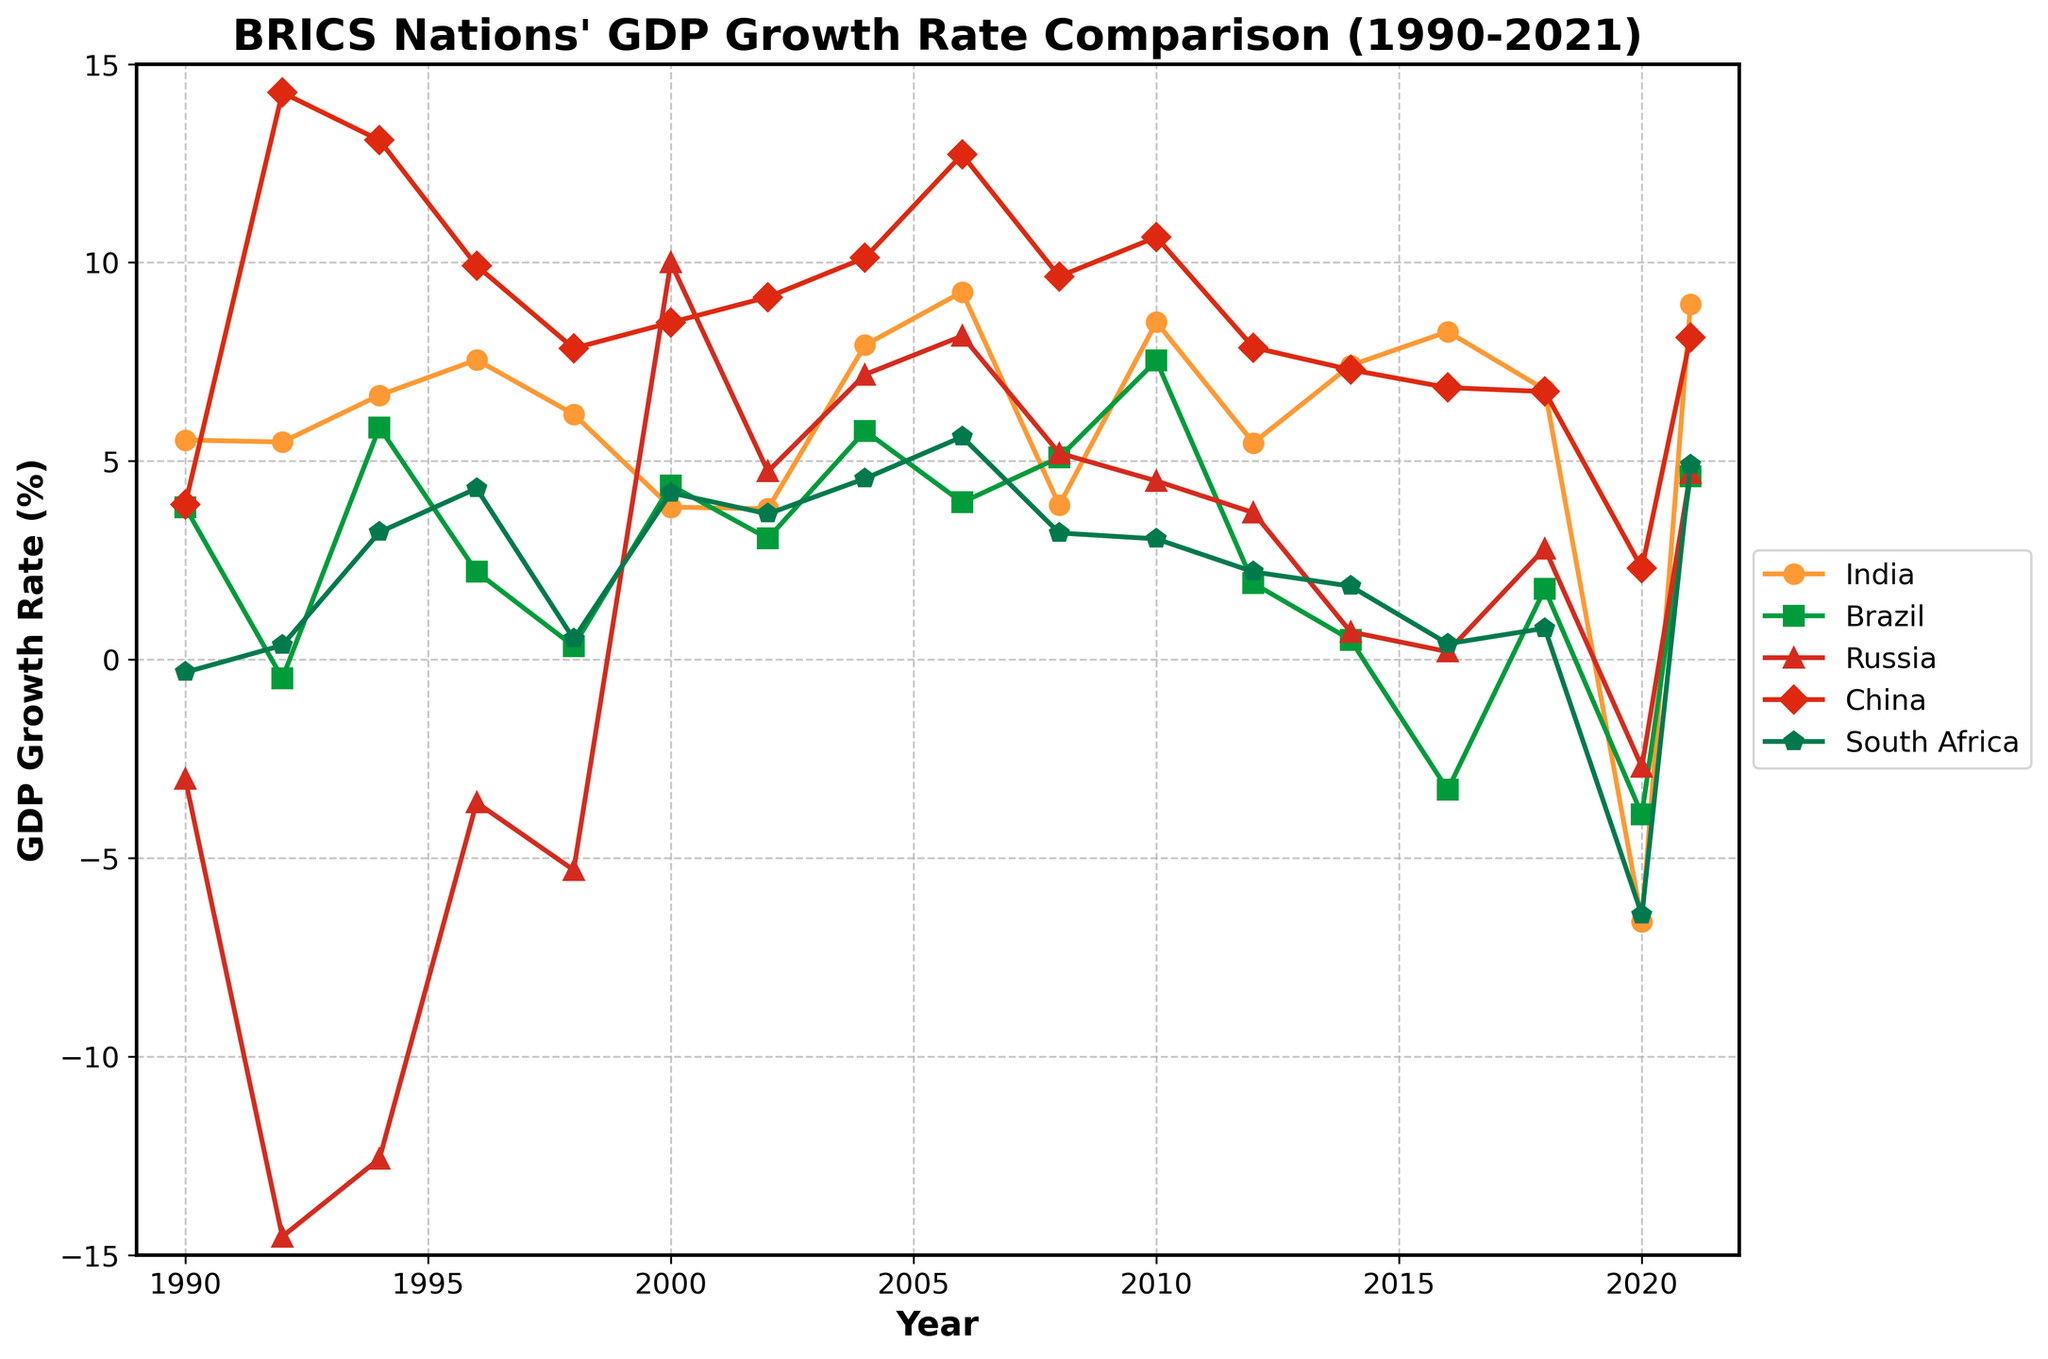What year did India experience its highest GDP growth rate, and what was the rate? To determine the highest GDP growth rate for India, find the peak point on India’s line in the plot. The peak point is at 2021, where India's GDP growth rate is 8.95%.
Answer: 2021, 8.95% Compare the GDP growth rates of India and Brazil in 2020. Which country had a lower rate? Locate the year 2020 on the x-axis and compare the points for India and Brazil. India's rate is -6.60%, while Brazil's rate is -3.90%. India has a lower growth rate.
Answer: India In which year did Russia have a negative GDP growth rate while both India and China had positive GDP growth rates? Identify the years where Russia's line is below the 0% axis and mark those years. Then check if India and China's lines are above the 0% axis in any of these years. In 1998, Russia had -5.3%, India had 6.18%, and China had 7.84%.
Answer: 1998 What is the average GDP growth rate for South Africa from 1990 to 2021? Sum all the GDP growth rates of South Africa for the years provided and divide by the number of years. The rates are (-0.32+0.36+3.21+4.31+0.52+4.2+3.67+4.56+5.61+3.19+3.04+2.21+1.85+0.4+0.79+-6.43+4.91)= 30.87. There are 17 years, so 30.87/17 ≈ 1.82.
Answer: 1.82% Which country had the most volatile GDP growth rate between 1990 and 2021? Volatility can be assessed by observing erratic movement in the lines. Russia’s line fluctuates significantly, including extreme negatives and high positives, indicating the most volatility.
Answer: Russia During which years did China consistently have a GDP growth rate above 10%? Look at China’s line and identify segments where it stays above the 10% mark. The consistent years are 1992 (14.28%), 1994 (13.08%), 2004 (10.12%), 2006 (12.72%), and 2010 (10.64%).
Answer: 1992, 1994, 2004, 2006, 2010 What was the overall trend of India’s GDP growth rate from 1990 to 2021? Increasing, decreasing, or fluctuation? Observing India’s line from start to end, it starts around 5.53% in 1990, peaks at multiple points and dips in between, leading to an overall fluctuating trend but generally showing an upward movement towards 2021.
Answer: Fluctuation Compare the GDP growth rates of China and Russia during the global financial crisis of 2008. Which country was less affected? Check the points in 2008 for China and Russia. China has 9.65% while Russia has 5.2%. China was less affected because it maintained higher positive growth.
Answer: China What is the difference in GDP growth rates between India and South Africa in 2010? Locate 2010 on the x-axis for both countries. India’s rate is 8.50% and South Africa’s is 3.04%. Difference = 8.50% - 3.04% = 5.46%.
Answer: 5.46% Between 1996 and 2002, which country had a consistent positive GDP growth rate every year? Inspect each country’s line for the given years. China and South Africa show consistent positive growth rates in each year within that range. However, a specific country is required. China maintains the highest and consistent positives.
Answer: China 